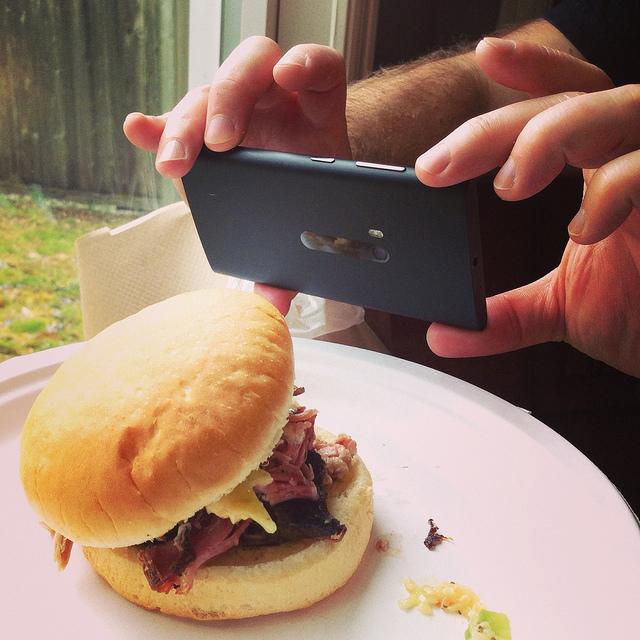Has this food been tasted yet?
Quick response, please. No. What is the person doing?
Write a very short answer. Taking picture. Would a vegetarian eat this?
Give a very brief answer. No. 